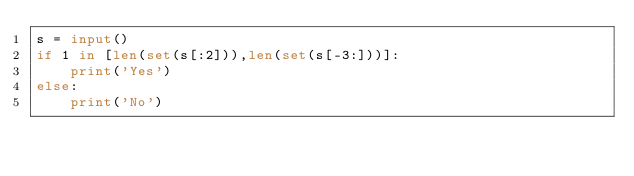Convert code to text. <code><loc_0><loc_0><loc_500><loc_500><_Python_>s = input()
if 1 in [len(set(s[:2])),len(set(s[-3:]))]:
    print('Yes')
else:
    print('No')</code> 